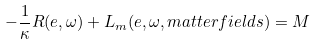<formula> <loc_0><loc_0><loc_500><loc_500>- \frac { 1 } { \kappa } R ( e , \omega ) + L _ { m } ( e , \omega , m a t t e r f i e l d s ) = M</formula> 